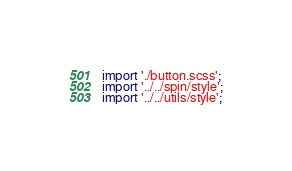Convert code to text. <code><loc_0><loc_0><loc_500><loc_500><_TypeScript_>import './button.scss';
import '../../spin/style';
import '../../utils/style';
</code> 